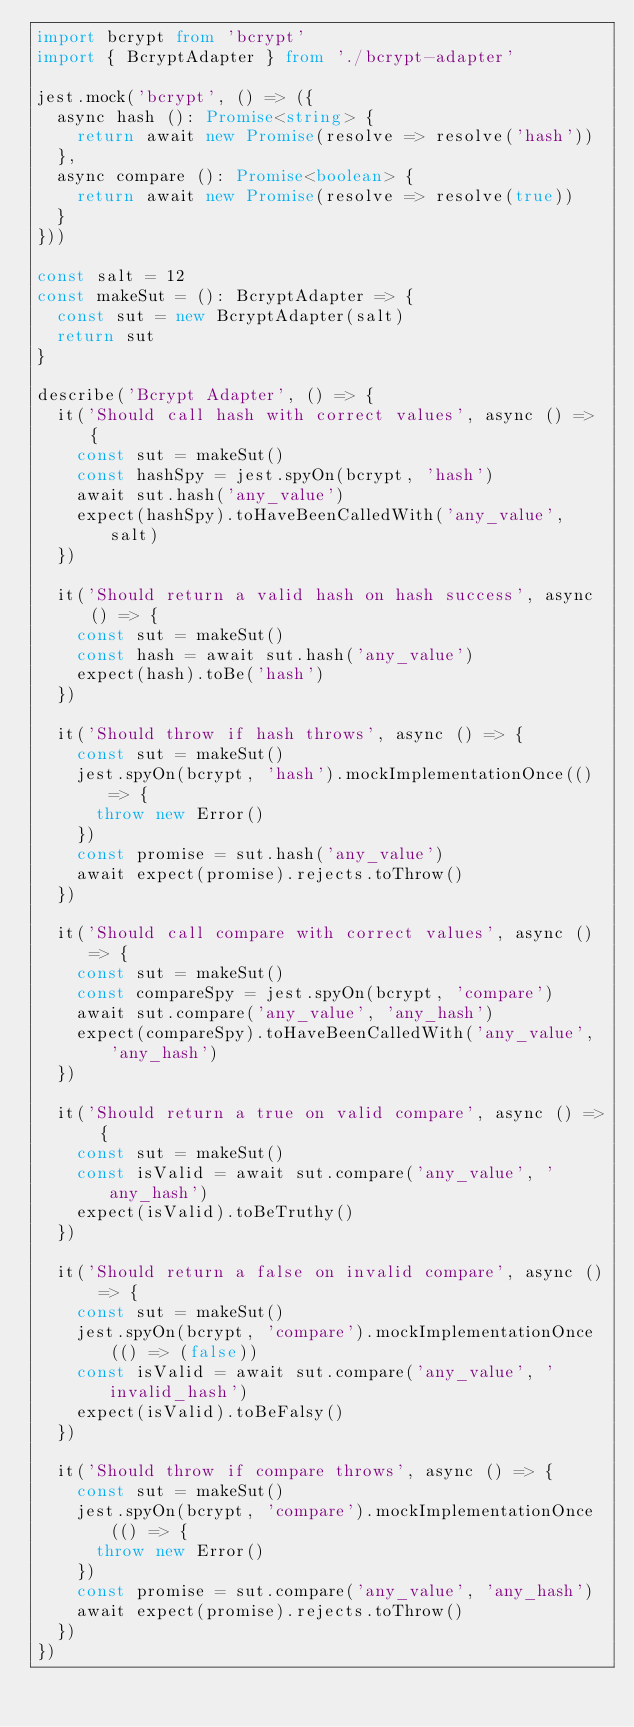Convert code to text. <code><loc_0><loc_0><loc_500><loc_500><_TypeScript_>import bcrypt from 'bcrypt'
import { BcryptAdapter } from './bcrypt-adapter'

jest.mock('bcrypt', () => ({
  async hash (): Promise<string> {
    return await new Promise(resolve => resolve('hash'))
  },
  async compare (): Promise<boolean> {
    return await new Promise(resolve => resolve(true))
  }
}))

const salt = 12
const makeSut = (): BcryptAdapter => {
  const sut = new BcryptAdapter(salt)
  return sut
}

describe('Bcrypt Adapter', () => {
  it('Should call hash with correct values', async () => {
    const sut = makeSut()
    const hashSpy = jest.spyOn(bcrypt, 'hash')
    await sut.hash('any_value')
    expect(hashSpy).toHaveBeenCalledWith('any_value', salt)
  })

  it('Should return a valid hash on hash success', async () => {
    const sut = makeSut()
    const hash = await sut.hash('any_value')
    expect(hash).toBe('hash')
  })

  it('Should throw if hash throws', async () => {
    const sut = makeSut()
    jest.spyOn(bcrypt, 'hash').mockImplementationOnce(() => {
      throw new Error()
    })
    const promise = sut.hash('any_value')
    await expect(promise).rejects.toThrow()
  })

  it('Should call compare with correct values', async () => {
    const sut = makeSut()
    const compareSpy = jest.spyOn(bcrypt, 'compare')
    await sut.compare('any_value', 'any_hash')
    expect(compareSpy).toHaveBeenCalledWith('any_value', 'any_hash')
  })

  it('Should return a true on valid compare', async () => {
    const sut = makeSut()
    const isValid = await sut.compare('any_value', 'any_hash')
    expect(isValid).toBeTruthy()
  })

  it('Should return a false on invalid compare', async () => {
    const sut = makeSut()
    jest.spyOn(bcrypt, 'compare').mockImplementationOnce(() => (false))
    const isValid = await sut.compare('any_value', 'invalid_hash')
    expect(isValid).toBeFalsy()
  })

  it('Should throw if compare throws', async () => {
    const sut = makeSut()
    jest.spyOn(bcrypt, 'compare').mockImplementationOnce(() => {
      throw new Error()
    })
    const promise = sut.compare('any_value', 'any_hash')
    await expect(promise).rejects.toThrow()
  })
})
</code> 